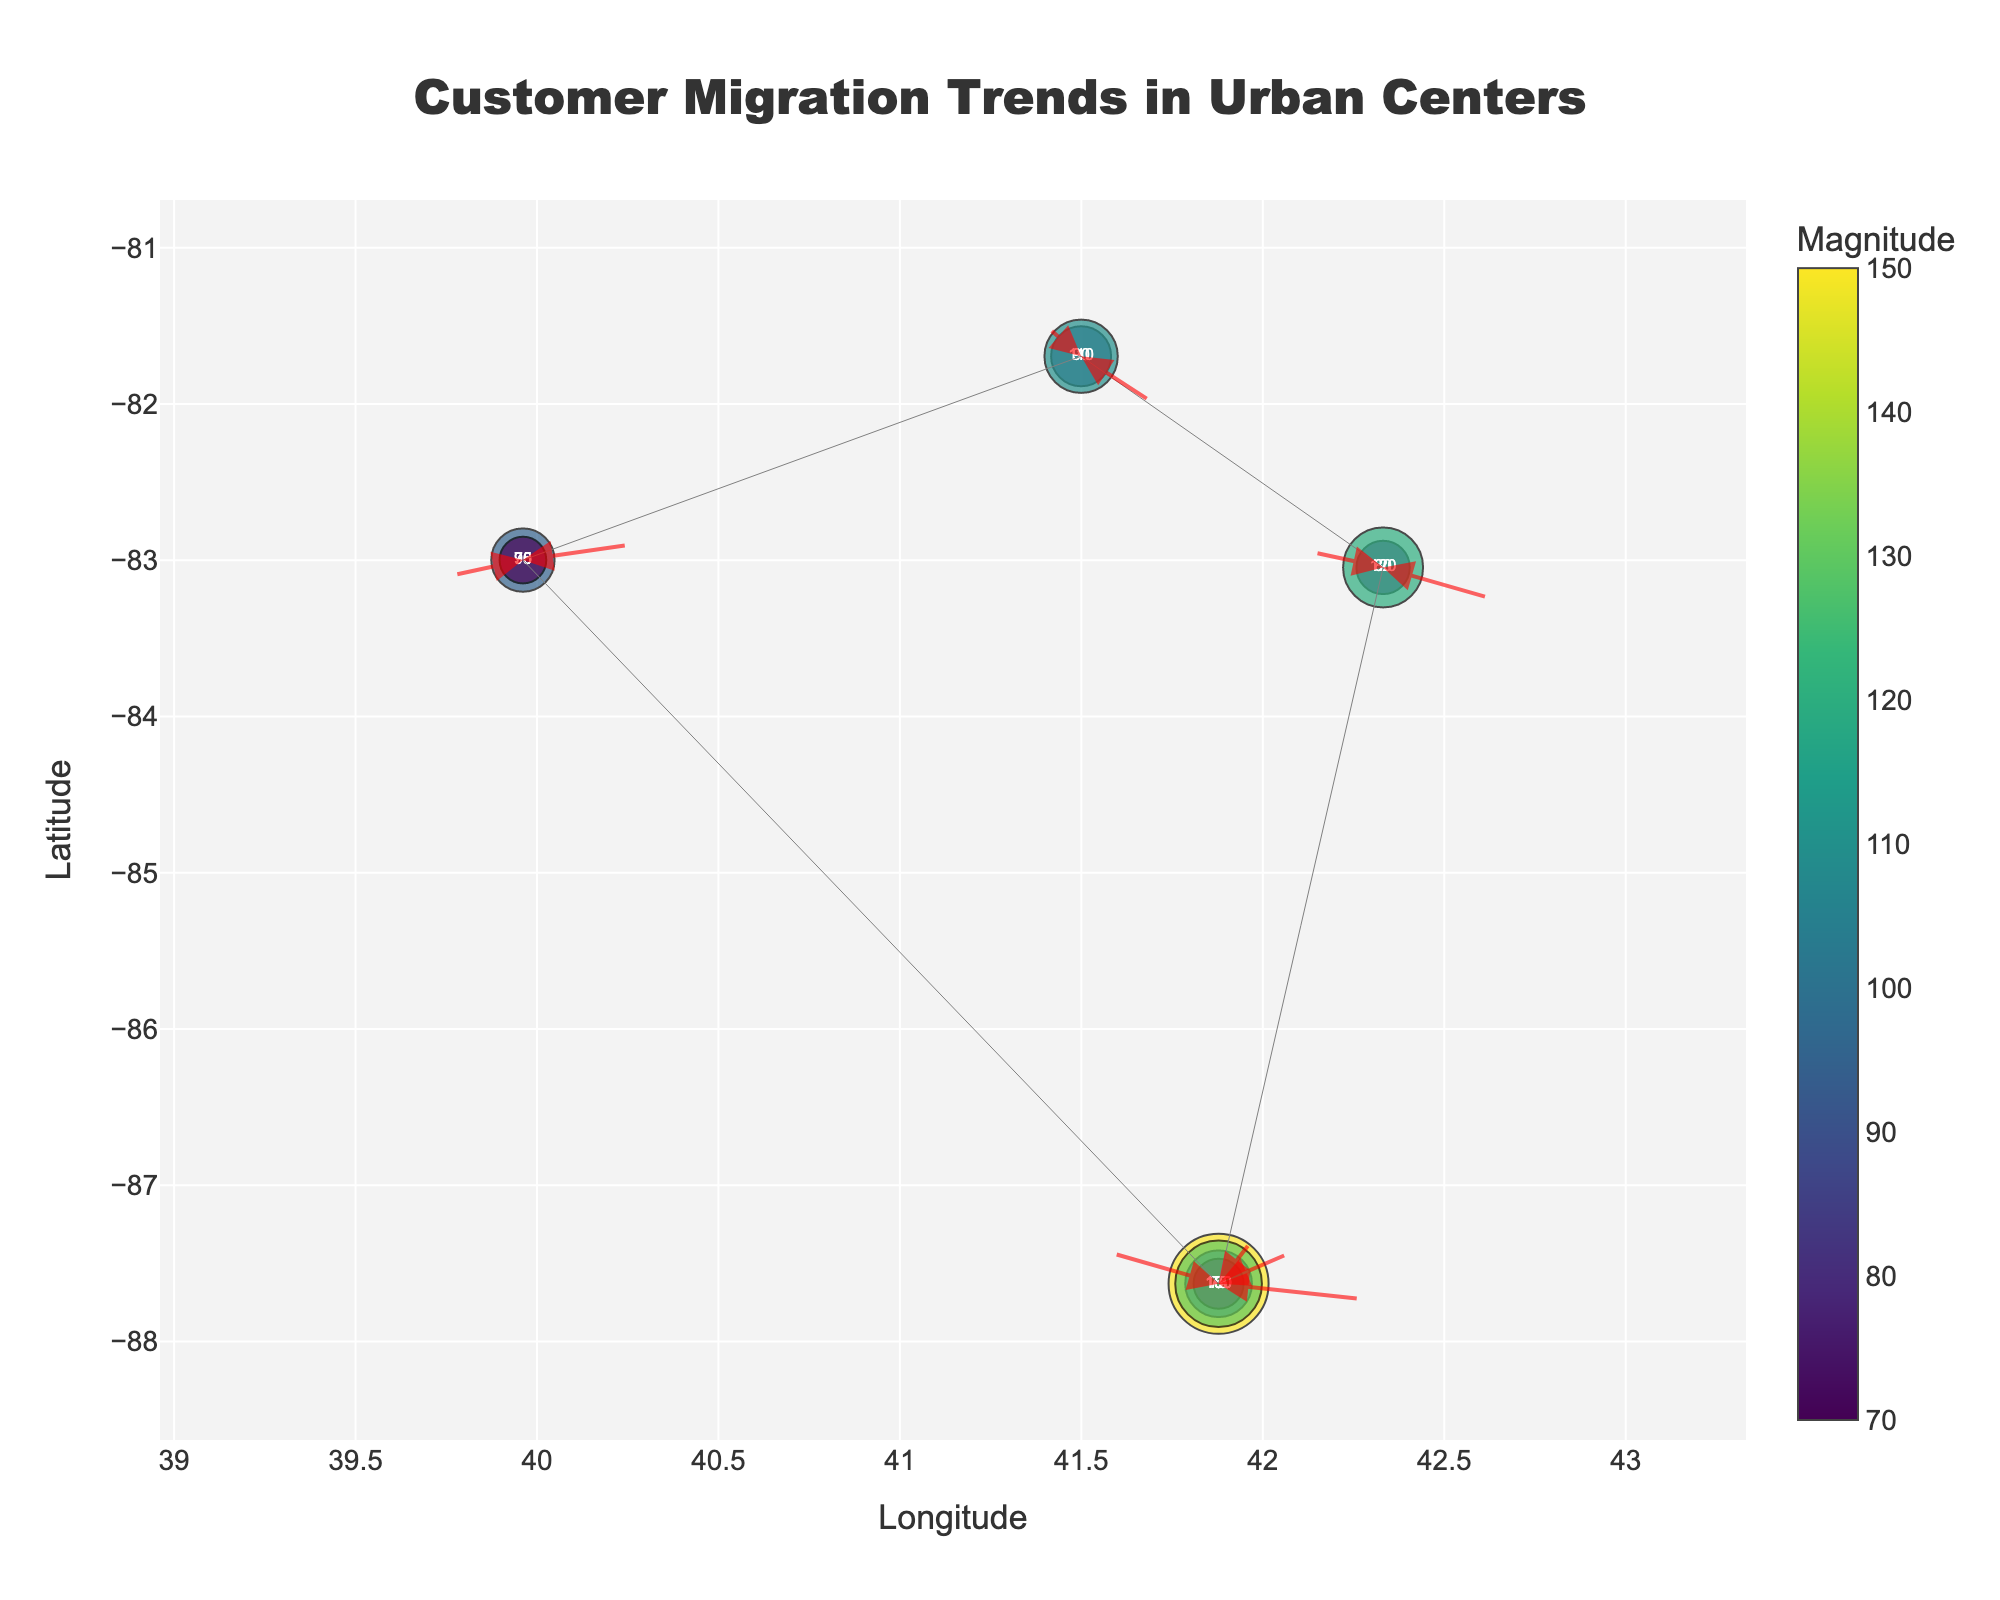What is the title of the figure? The title of the figure is displayed at the top center of the plot. It is typically highlighted in bold or a larger font size.
Answer: Customer Migration Trends in Urban Centers What are the x-axis and y-axis labels? The x-axis label indicates the horizontal coordinate, and the y-axis label indicates the vertical coordinate. They are typically displayed below and to the left of the plot, respectively.
Answer: Longitude and Latitude How many data points are marked on the figure? By counting the unique pairs of x and y coordinates where markers are placed, we can determine the number of data points.
Answer: 10 Which data point has the highest magnitude of customer migration? Look for the data point with the largest marker size and color intensity, as the color scale and size of the circles represent the magnitude.
Answer: (41.8781, -87.6298) with magnitude 150 What is the color of the marker with the lowest magnitude? Check the color scale to determine the color assigned to the smallest data point magnitude. The lowest magnitude corresponds to the lightest or least intense color in the scale.
Answer: Light yellow (magnitude 70) How many customer migrations are moving in the positive x direction? Count the number of arrows pointing towards the right (positive x direction).
Answer: 5 Which city has the majority of outward customer migrations? Check the coordinates to map them to city names and see where more arrows originate. Focus mainly on the latitude and longitude provided in the data.
Answer: Chicago (41.8781, -87.6298) What is the total magnitude of customer migrations originating from Chicago? Sum the magnitudes at the coordinates (41.8781, -87.6298).
Answer: 150 + 100 + 75 + 130 = 455 If customer migrations moving in the positive x and y direction are considered positive growth, which city shows the most positive growth? Check both the u and v columns for positive values and sum the magnitudes for respective coordinates.
Answer: Chicago (41.8781, -87.6298) with magnitudes 100, 75, 130 Which city has more migrations moving outward than inward between the longitude of -84 and -82? Identify the longitudinal range and check u values to see outward (-) and inward (+) movements. Count the arrows accordingly.
Answer: 39.9612, -82.9988 with 95 outgoing and 70 incoming 